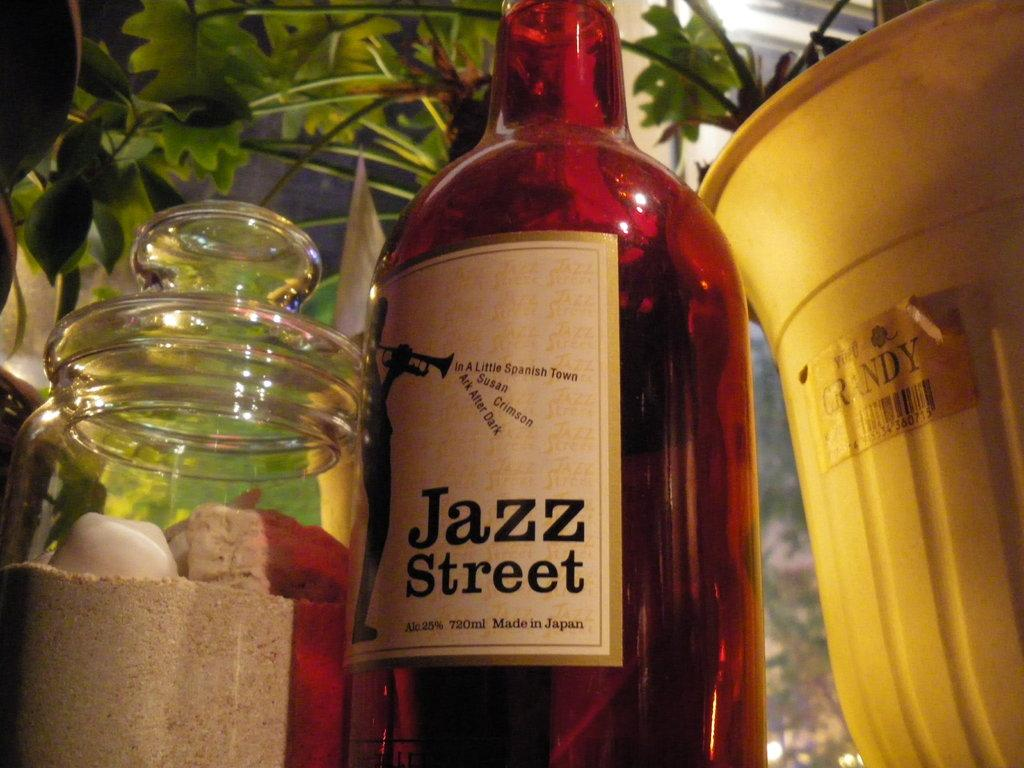<image>
Render a clear and concise summary of the photo. A brown bottle of Jazz Street is next to a yellow bucket. 